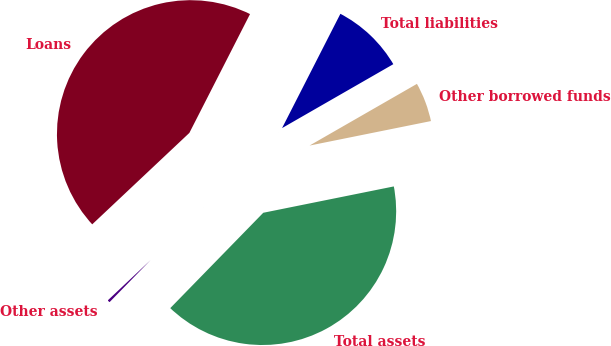Convert chart to OTSL. <chart><loc_0><loc_0><loc_500><loc_500><pie_chart><fcel>Loans<fcel>Other assets<fcel>Total assets<fcel>Other borrowed funds<fcel>Total liabilities<nl><fcel>44.53%<fcel>0.68%<fcel>40.47%<fcel>5.13%<fcel>9.19%<nl></chart> 